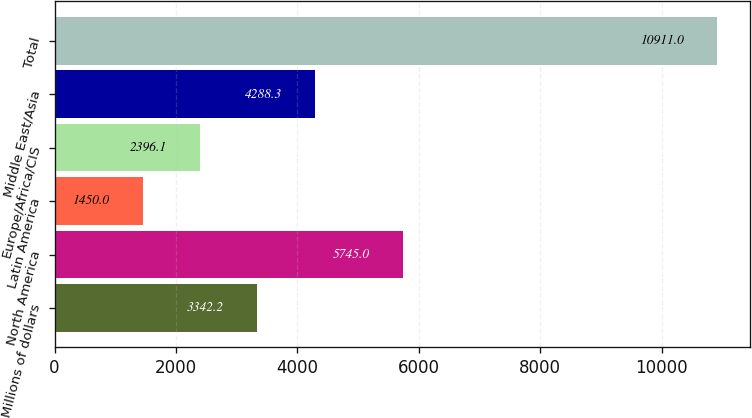Convert chart to OTSL. <chart><loc_0><loc_0><loc_500><loc_500><bar_chart><fcel>Millions of dollars<fcel>North America<fcel>Latin America<fcel>Europe/Africa/CIS<fcel>Middle East/Asia<fcel>Total<nl><fcel>3342.2<fcel>5745<fcel>1450<fcel>2396.1<fcel>4288.3<fcel>10911<nl></chart> 